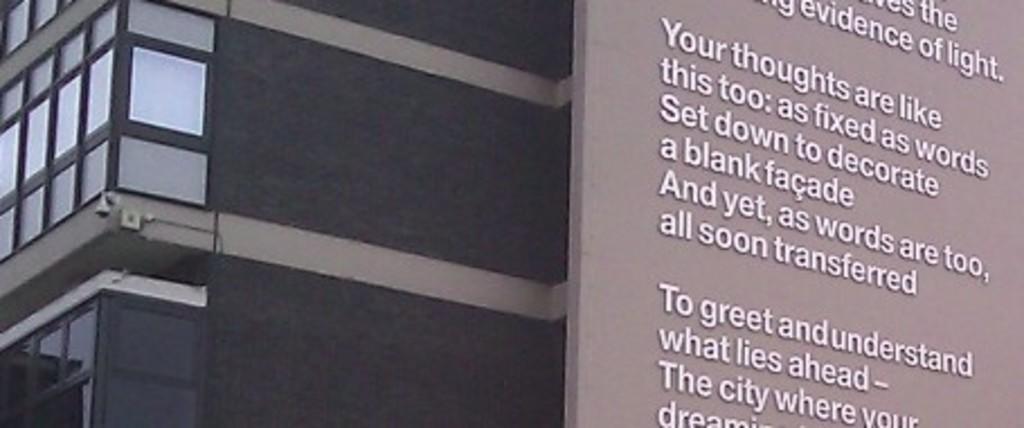How would you summarize this image in a sentence or two? On the right side, there are texts on a surface. On the left side, there are windows of a building. 